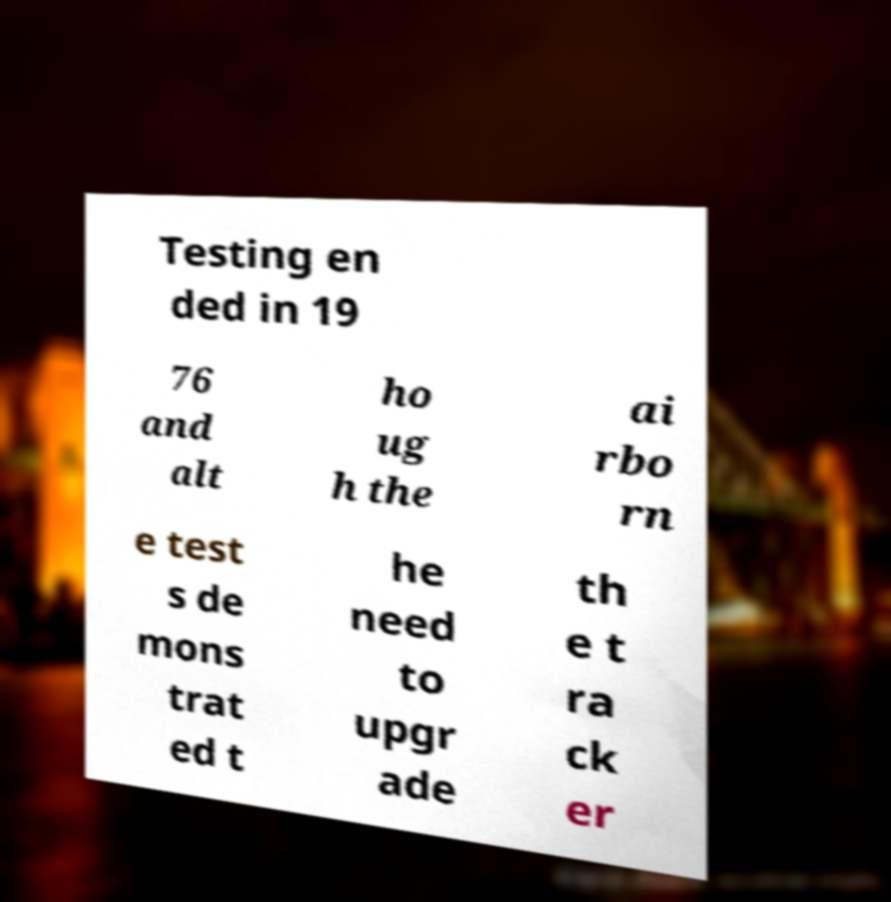Please read and relay the text visible in this image. What does it say? Testing en ded in 19 76 and alt ho ug h the ai rbo rn e test s de mons trat ed t he need to upgr ade th e t ra ck er 